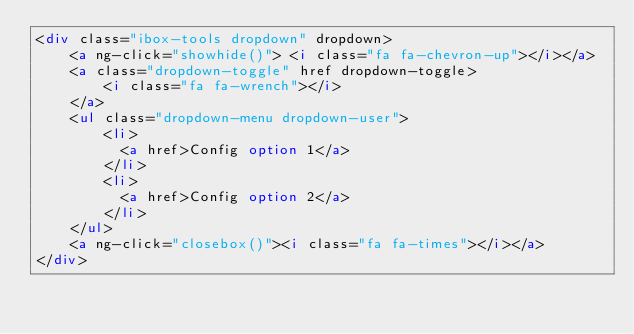Convert code to text. <code><loc_0><loc_0><loc_500><loc_500><_HTML_><div class="ibox-tools dropdown" dropdown>
    <a ng-click="showhide()"> <i class="fa fa-chevron-up"></i></a>
    <a class="dropdown-toggle" href dropdown-toggle>
        <i class="fa fa-wrench"></i>
    </a>
    <ul class="dropdown-menu dropdown-user">
        <li>
        	<a href>Config option 1</a>
        </li>
        <li>
        	<a href>Config option 2</a>
        </li>
    </ul>
    <a ng-click="closebox()"><i class="fa fa-times"></i></a>
</div></code> 